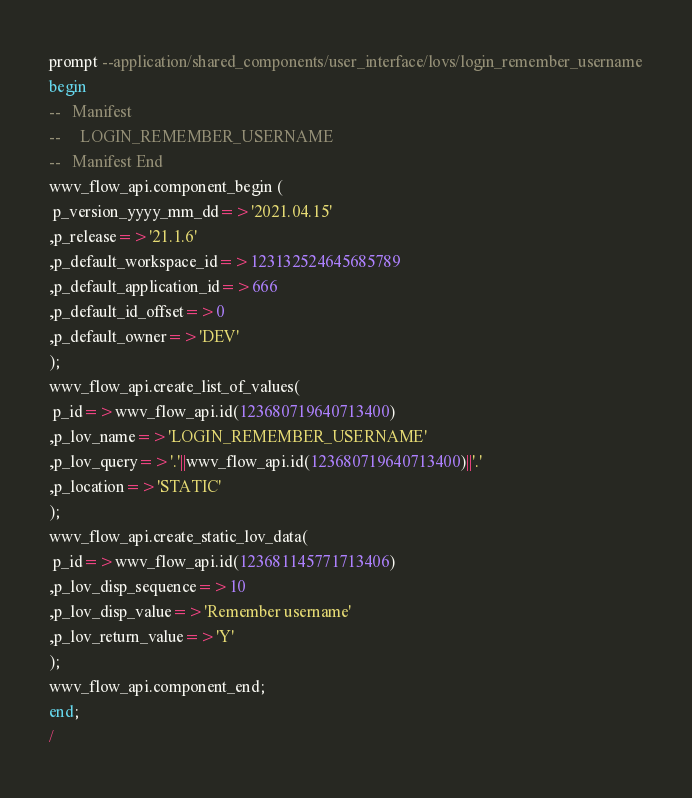Convert code to text. <code><loc_0><loc_0><loc_500><loc_500><_SQL_>prompt --application/shared_components/user_interface/lovs/login_remember_username
begin
--   Manifest
--     LOGIN_REMEMBER_USERNAME
--   Manifest End
wwv_flow_api.component_begin (
 p_version_yyyy_mm_dd=>'2021.04.15'
,p_release=>'21.1.6'
,p_default_workspace_id=>123132524645685789
,p_default_application_id=>666
,p_default_id_offset=>0
,p_default_owner=>'DEV'
);
wwv_flow_api.create_list_of_values(
 p_id=>wwv_flow_api.id(123680719640713400)
,p_lov_name=>'LOGIN_REMEMBER_USERNAME'
,p_lov_query=>'.'||wwv_flow_api.id(123680719640713400)||'.'
,p_location=>'STATIC'
);
wwv_flow_api.create_static_lov_data(
 p_id=>wwv_flow_api.id(123681145771713406)
,p_lov_disp_sequence=>10
,p_lov_disp_value=>'Remember username'
,p_lov_return_value=>'Y'
);
wwv_flow_api.component_end;
end;
/
</code> 